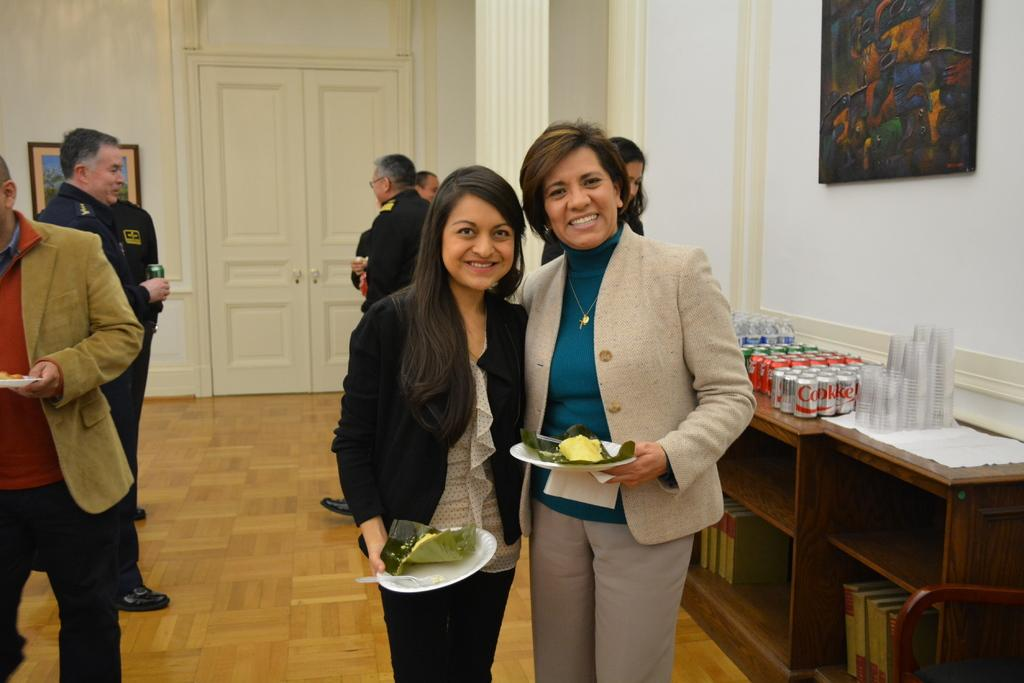How many people are visible in the image? There are two persons standing in the image. What are the two standing persons holding in their hands? The two persons are holding eatables in their hands. Can you describe the people behind the two standing persons? There are people behind the two standing persons, but their actions or items they are holding are not visible. What is present on the table in the image? There is a table in the image with tons and glasses on it. What type of toothpaste is being used by the fairies in the image? There are no fairies present in the image, and therefore no toothpaste can be observed. What type of beef is being served on the table in the image? There is no beef present on the table in the image; it has tons and glasses. 